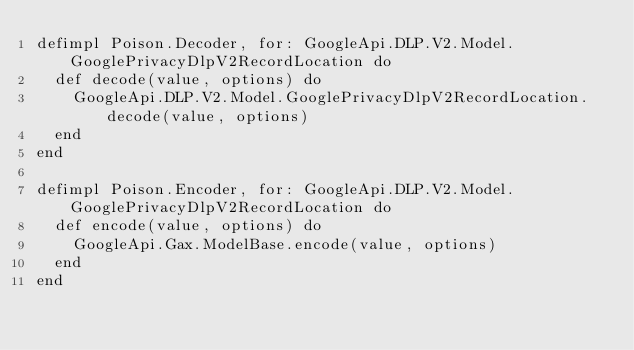Convert code to text. <code><loc_0><loc_0><loc_500><loc_500><_Elixir_>defimpl Poison.Decoder, for: GoogleApi.DLP.V2.Model.GooglePrivacyDlpV2RecordLocation do
  def decode(value, options) do
    GoogleApi.DLP.V2.Model.GooglePrivacyDlpV2RecordLocation.decode(value, options)
  end
end

defimpl Poison.Encoder, for: GoogleApi.DLP.V2.Model.GooglePrivacyDlpV2RecordLocation do
  def encode(value, options) do
    GoogleApi.Gax.ModelBase.encode(value, options)
  end
end
</code> 